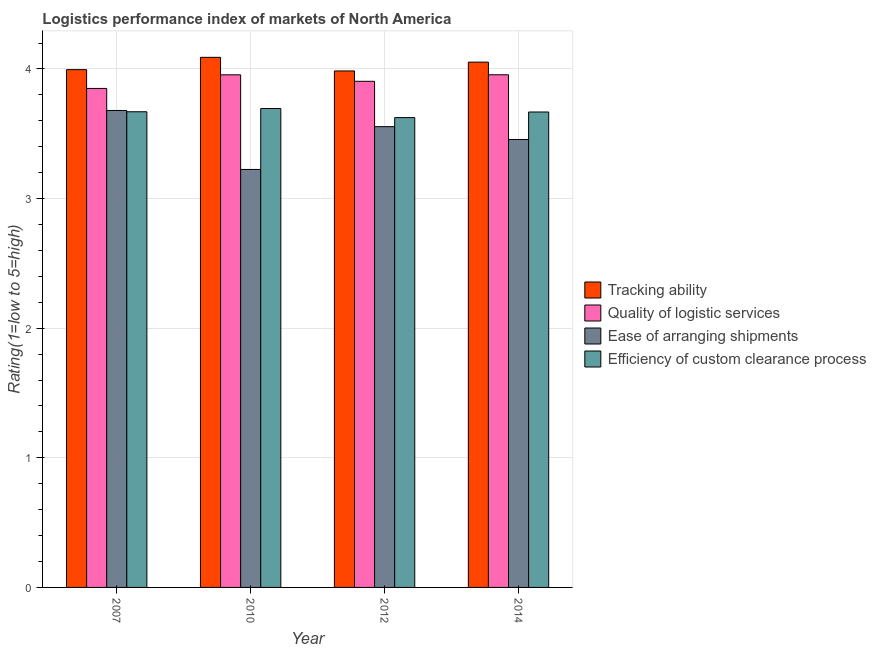Are the number of bars on each tick of the X-axis equal?
Offer a very short reply. Yes. What is the label of the 3rd group of bars from the left?
Your answer should be compact. 2012. What is the lpi rating of tracking ability in 2014?
Make the answer very short. 4.05. Across all years, what is the maximum lpi rating of quality of logistic services?
Your answer should be compact. 3.96. Across all years, what is the minimum lpi rating of quality of logistic services?
Offer a terse response. 3.85. In which year was the lpi rating of efficiency of custom clearance process maximum?
Provide a short and direct response. 2010. What is the total lpi rating of ease of arranging shipments in the graph?
Give a very brief answer. 13.92. What is the difference between the lpi rating of efficiency of custom clearance process in 2012 and that in 2014?
Keep it short and to the point. -0.04. What is the difference between the lpi rating of ease of arranging shipments in 2010 and the lpi rating of tracking ability in 2012?
Ensure brevity in your answer.  -0.33. What is the average lpi rating of ease of arranging shipments per year?
Provide a short and direct response. 3.48. What is the ratio of the lpi rating of tracking ability in 2012 to that in 2014?
Offer a terse response. 0.98. Is the difference between the lpi rating of tracking ability in 2012 and 2014 greater than the difference between the lpi rating of efficiency of custom clearance process in 2012 and 2014?
Your answer should be very brief. No. What is the difference between the highest and the second highest lpi rating of efficiency of custom clearance process?
Provide a short and direct response. 0.02. What is the difference between the highest and the lowest lpi rating of quality of logistic services?
Offer a terse response. 0.11. In how many years, is the lpi rating of tracking ability greater than the average lpi rating of tracking ability taken over all years?
Keep it short and to the point. 2. Is the sum of the lpi rating of efficiency of custom clearance process in 2010 and 2014 greater than the maximum lpi rating of quality of logistic services across all years?
Offer a terse response. Yes. What does the 4th bar from the left in 2014 represents?
Give a very brief answer. Efficiency of custom clearance process. What does the 1st bar from the right in 2014 represents?
Offer a very short reply. Efficiency of custom clearance process. How many bars are there?
Keep it short and to the point. 16. How many years are there in the graph?
Keep it short and to the point. 4. How many legend labels are there?
Give a very brief answer. 4. How are the legend labels stacked?
Offer a terse response. Vertical. What is the title of the graph?
Give a very brief answer. Logistics performance index of markets of North America. Does "Australia" appear as one of the legend labels in the graph?
Offer a very short reply. No. What is the label or title of the Y-axis?
Keep it short and to the point. Rating(1=low to 5=high). What is the Rating(1=low to 5=high) of Tracking ability in 2007?
Your answer should be compact. 4. What is the Rating(1=low to 5=high) in Quality of logistic services in 2007?
Make the answer very short. 3.85. What is the Rating(1=low to 5=high) in Ease of arranging shipments in 2007?
Give a very brief answer. 3.68. What is the Rating(1=low to 5=high) in Efficiency of custom clearance process in 2007?
Make the answer very short. 3.67. What is the Rating(1=low to 5=high) of Tracking ability in 2010?
Provide a succinct answer. 4.09. What is the Rating(1=low to 5=high) in Quality of logistic services in 2010?
Your answer should be very brief. 3.96. What is the Rating(1=low to 5=high) of Ease of arranging shipments in 2010?
Make the answer very short. 3.23. What is the Rating(1=low to 5=high) of Efficiency of custom clearance process in 2010?
Give a very brief answer. 3.69. What is the Rating(1=low to 5=high) in Tracking ability in 2012?
Offer a very short reply. 3.98. What is the Rating(1=low to 5=high) of Quality of logistic services in 2012?
Offer a very short reply. 3.9. What is the Rating(1=low to 5=high) of Ease of arranging shipments in 2012?
Your answer should be very brief. 3.56. What is the Rating(1=low to 5=high) in Efficiency of custom clearance process in 2012?
Give a very brief answer. 3.62. What is the Rating(1=low to 5=high) in Tracking ability in 2014?
Your response must be concise. 4.05. What is the Rating(1=low to 5=high) of Quality of logistic services in 2014?
Keep it short and to the point. 3.96. What is the Rating(1=low to 5=high) in Ease of arranging shipments in 2014?
Your answer should be compact. 3.46. What is the Rating(1=low to 5=high) in Efficiency of custom clearance process in 2014?
Your response must be concise. 3.67. Across all years, what is the maximum Rating(1=low to 5=high) of Tracking ability?
Offer a very short reply. 4.09. Across all years, what is the maximum Rating(1=low to 5=high) of Quality of logistic services?
Offer a terse response. 3.96. Across all years, what is the maximum Rating(1=low to 5=high) in Ease of arranging shipments?
Keep it short and to the point. 3.68. Across all years, what is the maximum Rating(1=low to 5=high) in Efficiency of custom clearance process?
Offer a very short reply. 3.69. Across all years, what is the minimum Rating(1=low to 5=high) of Tracking ability?
Give a very brief answer. 3.98. Across all years, what is the minimum Rating(1=low to 5=high) of Quality of logistic services?
Offer a very short reply. 3.85. Across all years, what is the minimum Rating(1=low to 5=high) in Ease of arranging shipments?
Make the answer very short. 3.23. Across all years, what is the minimum Rating(1=low to 5=high) in Efficiency of custom clearance process?
Provide a succinct answer. 3.62. What is the total Rating(1=low to 5=high) in Tracking ability in the graph?
Offer a very short reply. 16.12. What is the total Rating(1=low to 5=high) in Quality of logistic services in the graph?
Ensure brevity in your answer.  15.67. What is the total Rating(1=low to 5=high) in Ease of arranging shipments in the graph?
Offer a terse response. 13.92. What is the total Rating(1=low to 5=high) of Efficiency of custom clearance process in the graph?
Offer a very short reply. 14.66. What is the difference between the Rating(1=low to 5=high) in Tracking ability in 2007 and that in 2010?
Ensure brevity in your answer.  -0.1. What is the difference between the Rating(1=low to 5=high) in Quality of logistic services in 2007 and that in 2010?
Keep it short and to the point. -0.1. What is the difference between the Rating(1=low to 5=high) of Ease of arranging shipments in 2007 and that in 2010?
Give a very brief answer. 0.46. What is the difference between the Rating(1=low to 5=high) in Efficiency of custom clearance process in 2007 and that in 2010?
Provide a succinct answer. -0.03. What is the difference between the Rating(1=low to 5=high) in Quality of logistic services in 2007 and that in 2012?
Offer a very short reply. -0.06. What is the difference between the Rating(1=low to 5=high) of Efficiency of custom clearance process in 2007 and that in 2012?
Offer a very short reply. 0.04. What is the difference between the Rating(1=low to 5=high) of Tracking ability in 2007 and that in 2014?
Keep it short and to the point. -0.06. What is the difference between the Rating(1=low to 5=high) in Quality of logistic services in 2007 and that in 2014?
Make the answer very short. -0.11. What is the difference between the Rating(1=low to 5=high) of Ease of arranging shipments in 2007 and that in 2014?
Your response must be concise. 0.22. What is the difference between the Rating(1=low to 5=high) of Efficiency of custom clearance process in 2007 and that in 2014?
Offer a very short reply. 0. What is the difference between the Rating(1=low to 5=high) of Tracking ability in 2010 and that in 2012?
Make the answer very short. 0.1. What is the difference between the Rating(1=low to 5=high) of Ease of arranging shipments in 2010 and that in 2012?
Offer a very short reply. -0.33. What is the difference between the Rating(1=low to 5=high) in Efficiency of custom clearance process in 2010 and that in 2012?
Make the answer very short. 0.07. What is the difference between the Rating(1=low to 5=high) of Tracking ability in 2010 and that in 2014?
Make the answer very short. 0.04. What is the difference between the Rating(1=low to 5=high) in Quality of logistic services in 2010 and that in 2014?
Give a very brief answer. -0. What is the difference between the Rating(1=low to 5=high) in Ease of arranging shipments in 2010 and that in 2014?
Your answer should be very brief. -0.23. What is the difference between the Rating(1=low to 5=high) of Efficiency of custom clearance process in 2010 and that in 2014?
Ensure brevity in your answer.  0.03. What is the difference between the Rating(1=low to 5=high) of Tracking ability in 2012 and that in 2014?
Your answer should be very brief. -0.07. What is the difference between the Rating(1=low to 5=high) in Quality of logistic services in 2012 and that in 2014?
Your response must be concise. -0.05. What is the difference between the Rating(1=low to 5=high) of Ease of arranging shipments in 2012 and that in 2014?
Provide a succinct answer. 0.1. What is the difference between the Rating(1=low to 5=high) of Efficiency of custom clearance process in 2012 and that in 2014?
Give a very brief answer. -0.04. What is the difference between the Rating(1=low to 5=high) of Tracking ability in 2007 and the Rating(1=low to 5=high) of Quality of logistic services in 2010?
Offer a terse response. 0.04. What is the difference between the Rating(1=low to 5=high) of Tracking ability in 2007 and the Rating(1=low to 5=high) of Ease of arranging shipments in 2010?
Your response must be concise. 0.77. What is the difference between the Rating(1=low to 5=high) in Quality of logistic services in 2007 and the Rating(1=low to 5=high) in Efficiency of custom clearance process in 2010?
Provide a succinct answer. 0.15. What is the difference between the Rating(1=low to 5=high) in Ease of arranging shipments in 2007 and the Rating(1=low to 5=high) in Efficiency of custom clearance process in 2010?
Ensure brevity in your answer.  -0.01. What is the difference between the Rating(1=low to 5=high) in Tracking ability in 2007 and the Rating(1=low to 5=high) in Quality of logistic services in 2012?
Make the answer very short. 0.09. What is the difference between the Rating(1=low to 5=high) in Tracking ability in 2007 and the Rating(1=low to 5=high) in Ease of arranging shipments in 2012?
Provide a succinct answer. 0.44. What is the difference between the Rating(1=low to 5=high) in Tracking ability in 2007 and the Rating(1=low to 5=high) in Efficiency of custom clearance process in 2012?
Give a very brief answer. 0.37. What is the difference between the Rating(1=low to 5=high) of Quality of logistic services in 2007 and the Rating(1=low to 5=high) of Ease of arranging shipments in 2012?
Offer a very short reply. 0.29. What is the difference between the Rating(1=low to 5=high) of Quality of logistic services in 2007 and the Rating(1=low to 5=high) of Efficiency of custom clearance process in 2012?
Offer a very short reply. 0.23. What is the difference between the Rating(1=low to 5=high) in Ease of arranging shipments in 2007 and the Rating(1=low to 5=high) in Efficiency of custom clearance process in 2012?
Offer a very short reply. 0.06. What is the difference between the Rating(1=low to 5=high) of Tracking ability in 2007 and the Rating(1=low to 5=high) of Quality of logistic services in 2014?
Ensure brevity in your answer.  0.04. What is the difference between the Rating(1=low to 5=high) in Tracking ability in 2007 and the Rating(1=low to 5=high) in Ease of arranging shipments in 2014?
Offer a very short reply. 0.54. What is the difference between the Rating(1=low to 5=high) of Tracking ability in 2007 and the Rating(1=low to 5=high) of Efficiency of custom clearance process in 2014?
Give a very brief answer. 0.33. What is the difference between the Rating(1=low to 5=high) of Quality of logistic services in 2007 and the Rating(1=low to 5=high) of Ease of arranging shipments in 2014?
Offer a very short reply. 0.39. What is the difference between the Rating(1=low to 5=high) in Quality of logistic services in 2007 and the Rating(1=low to 5=high) in Efficiency of custom clearance process in 2014?
Offer a very short reply. 0.18. What is the difference between the Rating(1=low to 5=high) of Ease of arranging shipments in 2007 and the Rating(1=low to 5=high) of Efficiency of custom clearance process in 2014?
Make the answer very short. 0.01. What is the difference between the Rating(1=low to 5=high) in Tracking ability in 2010 and the Rating(1=low to 5=high) in Quality of logistic services in 2012?
Your answer should be compact. 0.18. What is the difference between the Rating(1=low to 5=high) in Tracking ability in 2010 and the Rating(1=low to 5=high) in Ease of arranging shipments in 2012?
Make the answer very short. 0.54. What is the difference between the Rating(1=low to 5=high) of Tracking ability in 2010 and the Rating(1=low to 5=high) of Efficiency of custom clearance process in 2012?
Your response must be concise. 0.47. What is the difference between the Rating(1=low to 5=high) of Quality of logistic services in 2010 and the Rating(1=low to 5=high) of Efficiency of custom clearance process in 2012?
Ensure brevity in your answer.  0.33. What is the difference between the Rating(1=low to 5=high) of Tracking ability in 2010 and the Rating(1=low to 5=high) of Quality of logistic services in 2014?
Offer a terse response. 0.13. What is the difference between the Rating(1=low to 5=high) in Tracking ability in 2010 and the Rating(1=low to 5=high) in Ease of arranging shipments in 2014?
Make the answer very short. 0.63. What is the difference between the Rating(1=low to 5=high) in Tracking ability in 2010 and the Rating(1=low to 5=high) in Efficiency of custom clearance process in 2014?
Make the answer very short. 0.42. What is the difference between the Rating(1=low to 5=high) of Quality of logistic services in 2010 and the Rating(1=low to 5=high) of Ease of arranging shipments in 2014?
Offer a very short reply. 0.5. What is the difference between the Rating(1=low to 5=high) in Quality of logistic services in 2010 and the Rating(1=low to 5=high) in Efficiency of custom clearance process in 2014?
Offer a terse response. 0.29. What is the difference between the Rating(1=low to 5=high) of Ease of arranging shipments in 2010 and the Rating(1=low to 5=high) of Efficiency of custom clearance process in 2014?
Provide a succinct answer. -0.44. What is the difference between the Rating(1=low to 5=high) in Tracking ability in 2012 and the Rating(1=low to 5=high) in Quality of logistic services in 2014?
Provide a succinct answer. 0.03. What is the difference between the Rating(1=low to 5=high) in Tracking ability in 2012 and the Rating(1=low to 5=high) in Ease of arranging shipments in 2014?
Your response must be concise. 0.53. What is the difference between the Rating(1=low to 5=high) of Tracking ability in 2012 and the Rating(1=low to 5=high) of Efficiency of custom clearance process in 2014?
Offer a terse response. 0.32. What is the difference between the Rating(1=low to 5=high) of Quality of logistic services in 2012 and the Rating(1=low to 5=high) of Ease of arranging shipments in 2014?
Your answer should be compact. 0.45. What is the difference between the Rating(1=low to 5=high) in Quality of logistic services in 2012 and the Rating(1=low to 5=high) in Efficiency of custom clearance process in 2014?
Make the answer very short. 0.24. What is the difference between the Rating(1=low to 5=high) of Ease of arranging shipments in 2012 and the Rating(1=low to 5=high) of Efficiency of custom clearance process in 2014?
Provide a succinct answer. -0.11. What is the average Rating(1=low to 5=high) in Tracking ability per year?
Offer a very short reply. 4.03. What is the average Rating(1=low to 5=high) in Quality of logistic services per year?
Give a very brief answer. 3.92. What is the average Rating(1=low to 5=high) of Ease of arranging shipments per year?
Your response must be concise. 3.48. What is the average Rating(1=low to 5=high) in Efficiency of custom clearance process per year?
Your response must be concise. 3.66. In the year 2007, what is the difference between the Rating(1=low to 5=high) of Tracking ability and Rating(1=low to 5=high) of Quality of logistic services?
Give a very brief answer. 0.14. In the year 2007, what is the difference between the Rating(1=low to 5=high) of Tracking ability and Rating(1=low to 5=high) of Ease of arranging shipments?
Keep it short and to the point. 0.32. In the year 2007, what is the difference between the Rating(1=low to 5=high) of Tracking ability and Rating(1=low to 5=high) of Efficiency of custom clearance process?
Provide a short and direct response. 0.33. In the year 2007, what is the difference between the Rating(1=low to 5=high) of Quality of logistic services and Rating(1=low to 5=high) of Ease of arranging shipments?
Your answer should be very brief. 0.17. In the year 2007, what is the difference between the Rating(1=low to 5=high) of Quality of logistic services and Rating(1=low to 5=high) of Efficiency of custom clearance process?
Offer a very short reply. 0.18. In the year 2007, what is the difference between the Rating(1=low to 5=high) of Ease of arranging shipments and Rating(1=low to 5=high) of Efficiency of custom clearance process?
Your response must be concise. 0.01. In the year 2010, what is the difference between the Rating(1=low to 5=high) in Tracking ability and Rating(1=low to 5=high) in Quality of logistic services?
Keep it short and to the point. 0.14. In the year 2010, what is the difference between the Rating(1=low to 5=high) in Tracking ability and Rating(1=low to 5=high) in Ease of arranging shipments?
Offer a terse response. 0.86. In the year 2010, what is the difference between the Rating(1=low to 5=high) in Tracking ability and Rating(1=low to 5=high) in Efficiency of custom clearance process?
Your answer should be compact. 0.4. In the year 2010, what is the difference between the Rating(1=low to 5=high) in Quality of logistic services and Rating(1=low to 5=high) in Ease of arranging shipments?
Offer a terse response. 0.73. In the year 2010, what is the difference between the Rating(1=low to 5=high) of Quality of logistic services and Rating(1=low to 5=high) of Efficiency of custom clearance process?
Provide a succinct answer. 0.26. In the year 2010, what is the difference between the Rating(1=low to 5=high) in Ease of arranging shipments and Rating(1=low to 5=high) in Efficiency of custom clearance process?
Your response must be concise. -0.47. In the year 2012, what is the difference between the Rating(1=low to 5=high) of Tracking ability and Rating(1=low to 5=high) of Ease of arranging shipments?
Give a very brief answer. 0.43. In the year 2012, what is the difference between the Rating(1=low to 5=high) in Tracking ability and Rating(1=low to 5=high) in Efficiency of custom clearance process?
Keep it short and to the point. 0.36. In the year 2012, what is the difference between the Rating(1=low to 5=high) in Quality of logistic services and Rating(1=low to 5=high) in Ease of arranging shipments?
Make the answer very short. 0.35. In the year 2012, what is the difference between the Rating(1=low to 5=high) of Quality of logistic services and Rating(1=low to 5=high) of Efficiency of custom clearance process?
Provide a succinct answer. 0.28. In the year 2012, what is the difference between the Rating(1=low to 5=high) in Ease of arranging shipments and Rating(1=low to 5=high) in Efficiency of custom clearance process?
Your answer should be compact. -0.07. In the year 2014, what is the difference between the Rating(1=low to 5=high) in Tracking ability and Rating(1=low to 5=high) in Quality of logistic services?
Keep it short and to the point. 0.1. In the year 2014, what is the difference between the Rating(1=low to 5=high) in Tracking ability and Rating(1=low to 5=high) in Ease of arranging shipments?
Provide a succinct answer. 0.6. In the year 2014, what is the difference between the Rating(1=low to 5=high) of Tracking ability and Rating(1=low to 5=high) of Efficiency of custom clearance process?
Ensure brevity in your answer.  0.38. In the year 2014, what is the difference between the Rating(1=low to 5=high) in Quality of logistic services and Rating(1=low to 5=high) in Ease of arranging shipments?
Your answer should be very brief. 0.5. In the year 2014, what is the difference between the Rating(1=low to 5=high) of Quality of logistic services and Rating(1=low to 5=high) of Efficiency of custom clearance process?
Give a very brief answer. 0.29. In the year 2014, what is the difference between the Rating(1=low to 5=high) of Ease of arranging shipments and Rating(1=low to 5=high) of Efficiency of custom clearance process?
Ensure brevity in your answer.  -0.21. What is the ratio of the Rating(1=low to 5=high) of Tracking ability in 2007 to that in 2010?
Offer a terse response. 0.98. What is the ratio of the Rating(1=low to 5=high) in Quality of logistic services in 2007 to that in 2010?
Provide a succinct answer. 0.97. What is the ratio of the Rating(1=low to 5=high) of Ease of arranging shipments in 2007 to that in 2010?
Provide a short and direct response. 1.14. What is the ratio of the Rating(1=low to 5=high) of Efficiency of custom clearance process in 2007 to that in 2010?
Make the answer very short. 0.99. What is the ratio of the Rating(1=low to 5=high) in Quality of logistic services in 2007 to that in 2012?
Your response must be concise. 0.99. What is the ratio of the Rating(1=low to 5=high) in Ease of arranging shipments in 2007 to that in 2012?
Your answer should be compact. 1.04. What is the ratio of the Rating(1=low to 5=high) of Efficiency of custom clearance process in 2007 to that in 2012?
Provide a succinct answer. 1.01. What is the ratio of the Rating(1=low to 5=high) in Tracking ability in 2007 to that in 2014?
Offer a terse response. 0.99. What is the ratio of the Rating(1=low to 5=high) of Quality of logistic services in 2007 to that in 2014?
Provide a short and direct response. 0.97. What is the ratio of the Rating(1=low to 5=high) of Ease of arranging shipments in 2007 to that in 2014?
Keep it short and to the point. 1.06. What is the ratio of the Rating(1=low to 5=high) in Tracking ability in 2010 to that in 2012?
Keep it short and to the point. 1.03. What is the ratio of the Rating(1=low to 5=high) in Quality of logistic services in 2010 to that in 2012?
Your response must be concise. 1.01. What is the ratio of the Rating(1=low to 5=high) of Ease of arranging shipments in 2010 to that in 2012?
Offer a very short reply. 0.91. What is the ratio of the Rating(1=low to 5=high) of Efficiency of custom clearance process in 2010 to that in 2012?
Provide a short and direct response. 1.02. What is the ratio of the Rating(1=low to 5=high) in Tracking ability in 2010 to that in 2014?
Offer a terse response. 1.01. What is the ratio of the Rating(1=low to 5=high) of Ease of arranging shipments in 2010 to that in 2014?
Your answer should be very brief. 0.93. What is the ratio of the Rating(1=low to 5=high) of Efficiency of custom clearance process in 2010 to that in 2014?
Offer a terse response. 1.01. What is the ratio of the Rating(1=low to 5=high) of Tracking ability in 2012 to that in 2014?
Make the answer very short. 0.98. What is the ratio of the Rating(1=low to 5=high) in Quality of logistic services in 2012 to that in 2014?
Provide a short and direct response. 0.99. What is the ratio of the Rating(1=low to 5=high) in Ease of arranging shipments in 2012 to that in 2014?
Offer a very short reply. 1.03. What is the difference between the highest and the second highest Rating(1=low to 5=high) of Tracking ability?
Provide a short and direct response. 0.04. What is the difference between the highest and the second highest Rating(1=low to 5=high) in Ease of arranging shipments?
Provide a short and direct response. 0.12. What is the difference between the highest and the second highest Rating(1=low to 5=high) in Efficiency of custom clearance process?
Offer a very short reply. 0.03. What is the difference between the highest and the lowest Rating(1=low to 5=high) in Tracking ability?
Offer a very short reply. 0.1. What is the difference between the highest and the lowest Rating(1=low to 5=high) of Quality of logistic services?
Give a very brief answer. 0.11. What is the difference between the highest and the lowest Rating(1=low to 5=high) of Ease of arranging shipments?
Keep it short and to the point. 0.46. What is the difference between the highest and the lowest Rating(1=low to 5=high) in Efficiency of custom clearance process?
Provide a succinct answer. 0.07. 